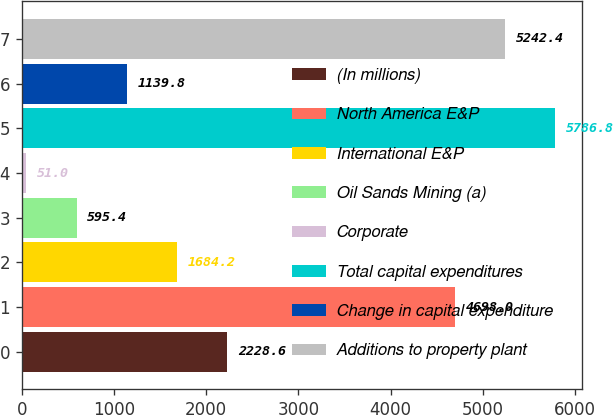Convert chart to OTSL. <chart><loc_0><loc_0><loc_500><loc_500><bar_chart><fcel>(In millions)<fcel>North America E&P<fcel>International E&P<fcel>Oil Sands Mining (a)<fcel>Corporate<fcel>Total capital expenditures<fcel>Change in capital expenditure<fcel>Additions to property plant<nl><fcel>2228.6<fcel>4698<fcel>1684.2<fcel>595.4<fcel>51<fcel>5786.8<fcel>1139.8<fcel>5242.4<nl></chart> 